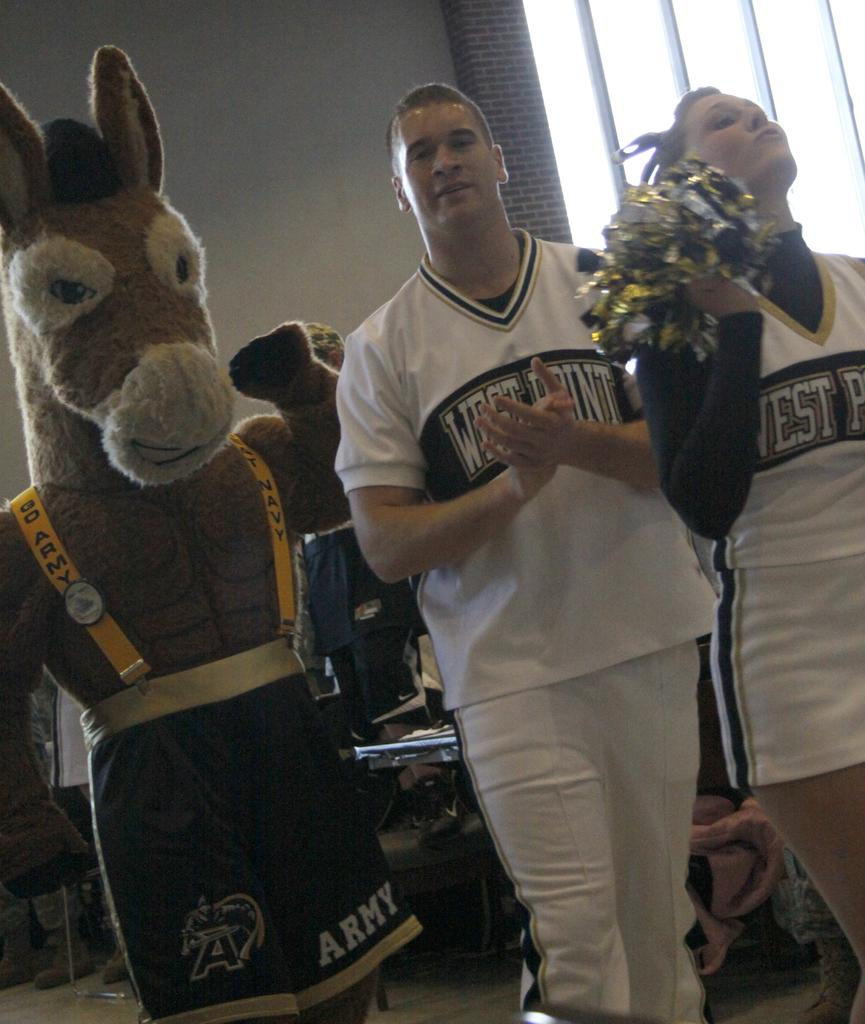<image>
Write a terse but informative summary of the picture. Cheerleaders for West Point are walking with a mascot in army shorts. 